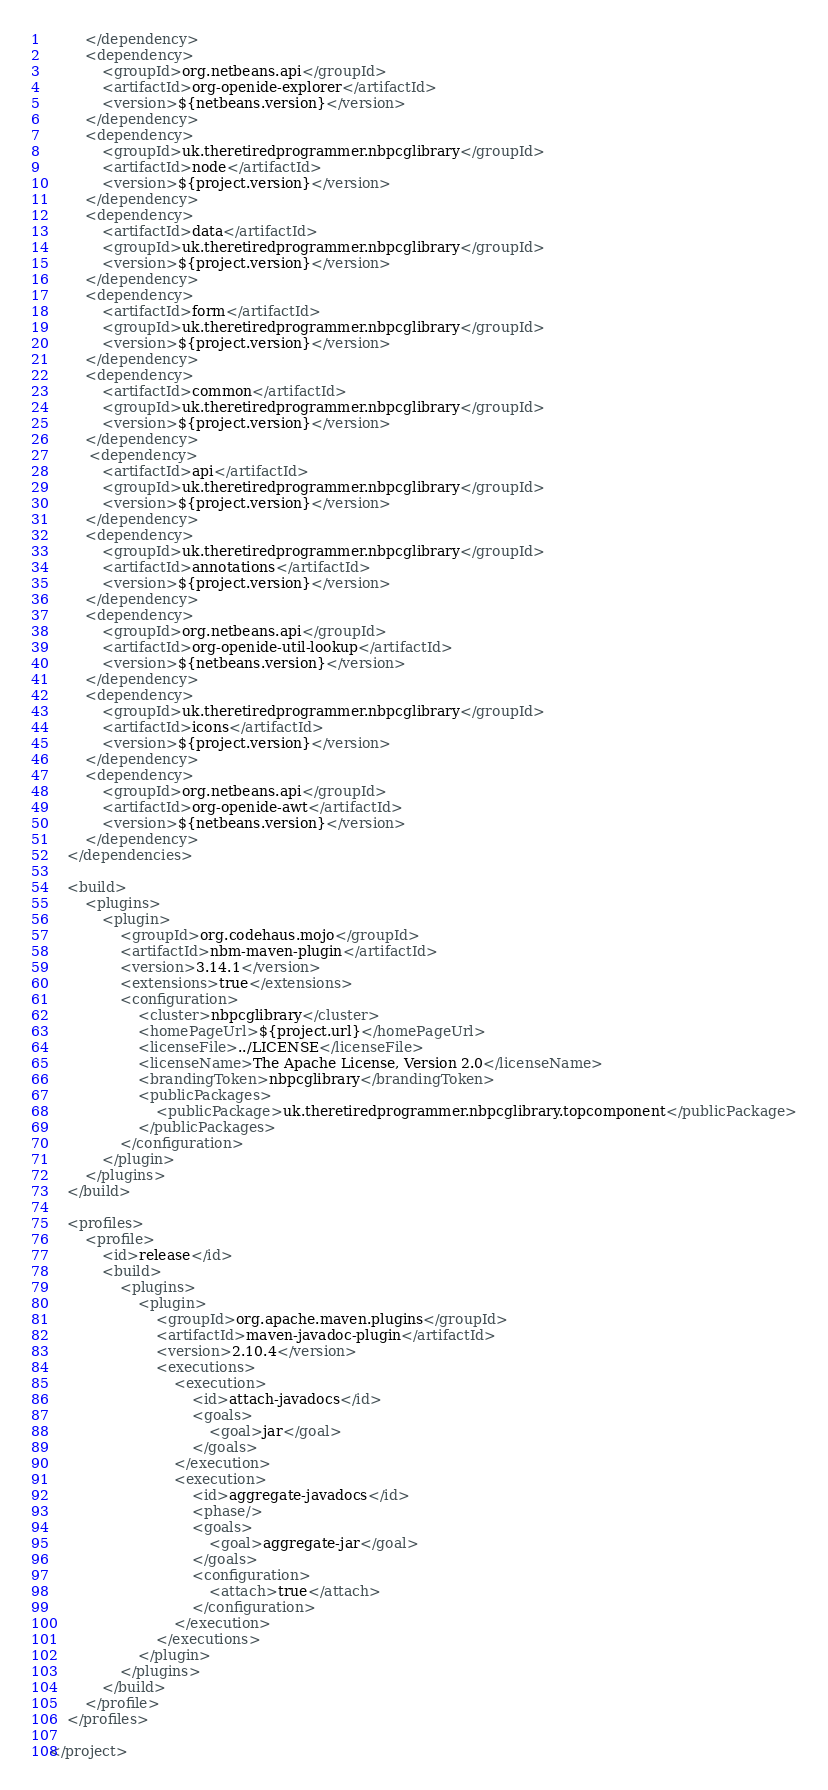<code> <loc_0><loc_0><loc_500><loc_500><_XML_>        </dependency>
        <dependency>
            <groupId>org.netbeans.api</groupId>
            <artifactId>org-openide-explorer</artifactId>
            <version>${netbeans.version}</version>
        </dependency>
        <dependency>
            <groupId>uk.theretiredprogrammer.nbpcglibrary</groupId>
            <artifactId>node</artifactId>
            <version>${project.version}</version>
        </dependency>
        <dependency>
            <artifactId>data</artifactId>
            <groupId>uk.theretiredprogrammer.nbpcglibrary</groupId>
            <version>${project.version}</version>
        </dependency>
        <dependency>
            <artifactId>form</artifactId>
            <groupId>uk.theretiredprogrammer.nbpcglibrary</groupId>
            <version>${project.version}</version>
        </dependency>
        <dependency>
            <artifactId>common</artifactId>
            <groupId>uk.theretiredprogrammer.nbpcglibrary</groupId>
            <version>${project.version}</version>
        </dependency>
         <dependency>
            <artifactId>api</artifactId>
            <groupId>uk.theretiredprogrammer.nbpcglibrary</groupId>
            <version>${project.version}</version>
        </dependency>
        <dependency>
            <groupId>uk.theretiredprogrammer.nbpcglibrary</groupId>
            <artifactId>annotations</artifactId>
            <version>${project.version}</version>
        </dependency>
        <dependency>
            <groupId>org.netbeans.api</groupId>
            <artifactId>org-openide-util-lookup</artifactId>
            <version>${netbeans.version}</version>
        </dependency>
        <dependency>
            <groupId>uk.theretiredprogrammer.nbpcglibrary</groupId>
            <artifactId>icons</artifactId>
            <version>${project.version}</version>
        </dependency>
        <dependency>
            <groupId>org.netbeans.api</groupId>
            <artifactId>org-openide-awt</artifactId>
            <version>${netbeans.version}</version>
        </dependency>
    </dependencies>

    <build>
        <plugins>
            <plugin>
                <groupId>org.codehaus.mojo</groupId>
                <artifactId>nbm-maven-plugin</artifactId>
                <version>3.14.1</version>
                <extensions>true</extensions>
                <configuration>
                    <cluster>nbpcglibrary</cluster>
                    <homePageUrl>${project.url}</homePageUrl>
                    <licenseFile>../LICENSE</licenseFile>
                    <licenseName>The Apache License, Version 2.0</licenseName>
                    <brandingToken>nbpcglibrary</brandingToken>
                    <publicPackages>
                        <publicPackage>uk.theretiredprogrammer.nbpcglibrary.topcomponent</publicPackage>
                    </publicPackages>
                </configuration>
            </plugin>
        </plugins>
    </build>
    
    <profiles>
        <profile>
            <id>release</id>
            <build>
                <plugins>
                    <plugin>
                        <groupId>org.apache.maven.plugins</groupId>
                        <artifactId>maven-javadoc-plugin</artifactId>
                        <version>2.10.4</version>
                        <executions>
                            <execution>
                                <id>attach-javadocs</id>
                                <goals>
                                    <goal>jar</goal>
                                </goals>
                            </execution>
                            <execution>
                                <id>aggregate-javadocs</id>
                                <phase/>
                                <goals>
                                    <goal>aggregate-jar</goal>
                                </goals>
                                <configuration>
                                    <attach>true</attach>
                                </configuration>
                            </execution>
                        </executions>
                    </plugin>
                </plugins>
            </build>
        </profile>
    </profiles>
    
</project></code> 